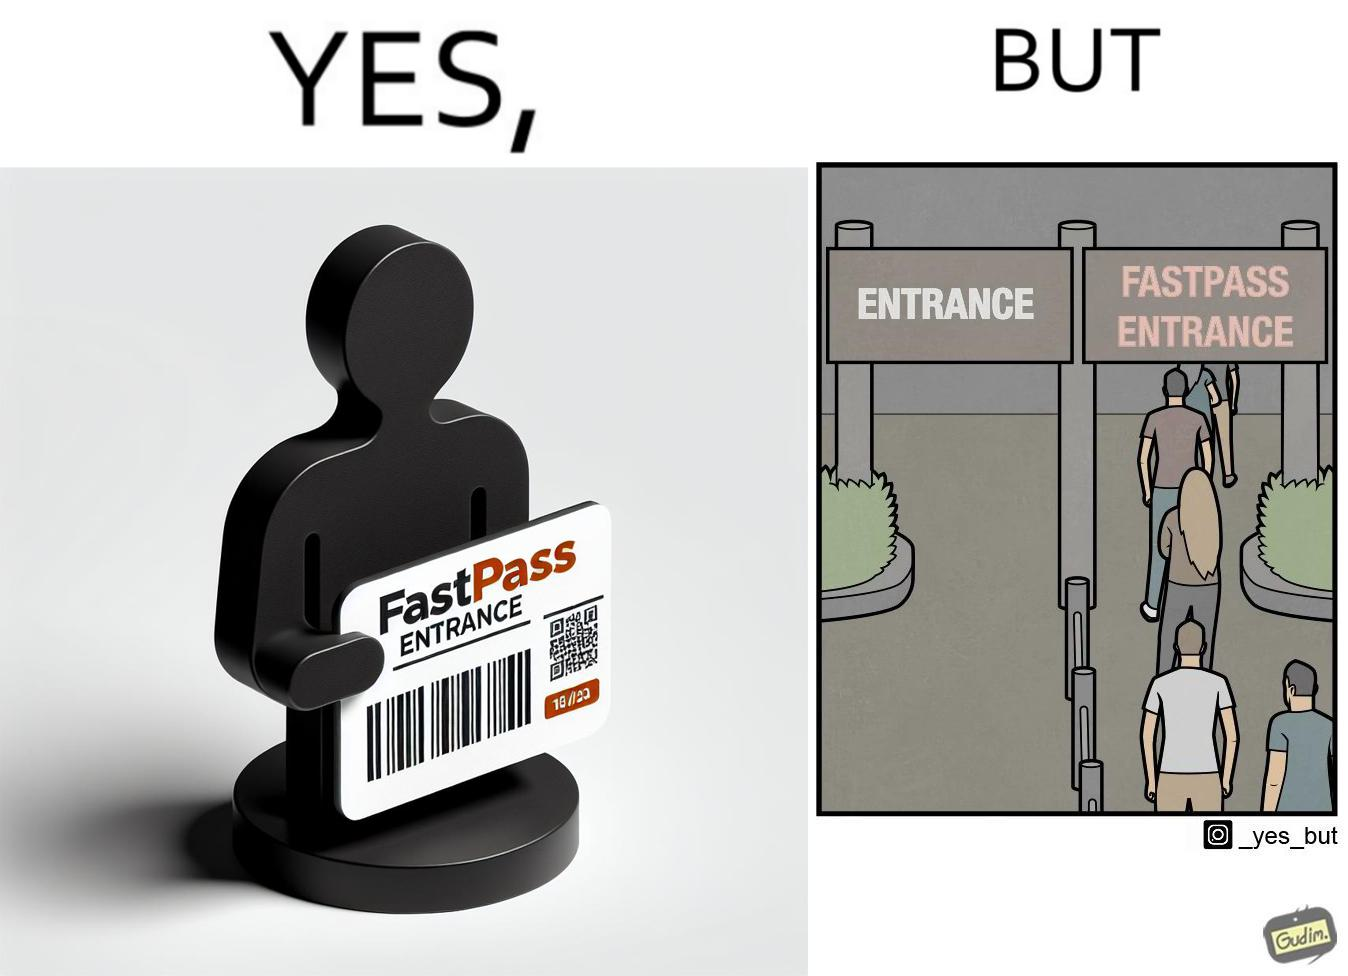Does this image contain satire or humor? Yes, this image is satirical. 